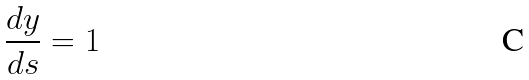<formula> <loc_0><loc_0><loc_500><loc_500>\frac { d y } { d s } = 1</formula> 